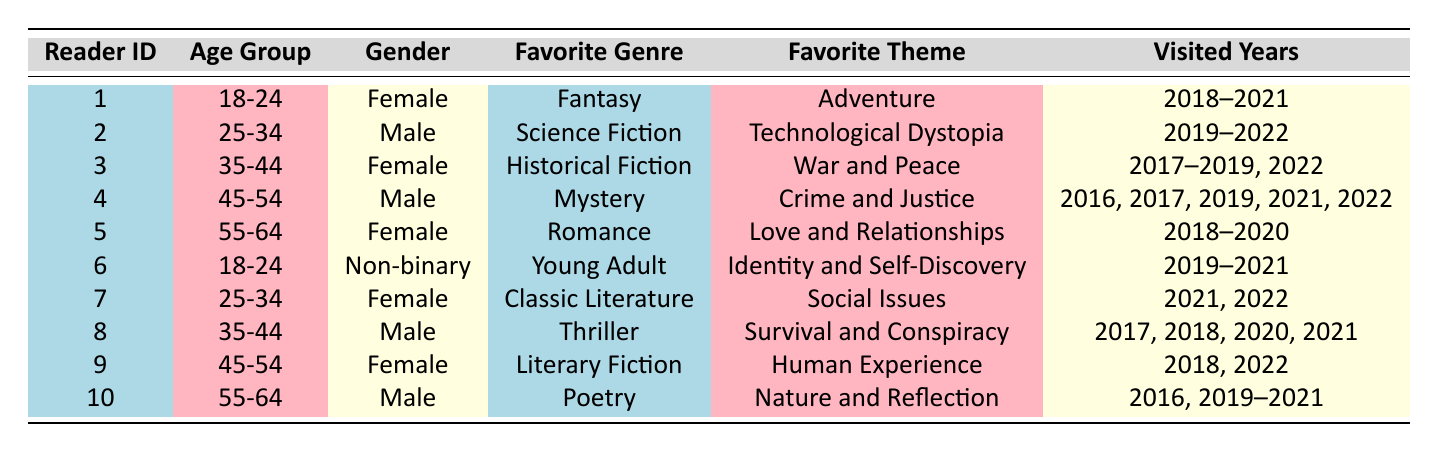What is the favorite genre of the youngest reader? The youngest reader is in the age group 18-24, and looking at the table, we see two readers in this group: Reader 1 and Reader 6. Reader 1's favorite genre is Fantasy, and Reader 6's favorite genre is Young Adult. Since both belong to the same age group, we can state that the favorite genres for the youngest readers are Fantasy and Young Adult.
Answer: Fantasy and Young Adult How many readers have the favorite theme "Social Issues"? To find the number of readers with the favorite theme "Social Issues," we can refer to the table and check for occurrences of this theme. Reader 7 has the theme "Social Issues." As there is only one reader associated with this theme, the count is 1.
Answer: 1 Is there any reader who enjoys both Poetry and the theme "Nature and Reflection"? Checking the table, we find that Reader 10 has the favorite genre of Poetry and the favorite theme of Nature and Reflection. Therefore, there is indeed a reader who enjoys both.
Answer: Yes What is the most common favorite genre among the readers in the age groups 35-44 and 45-54? We need to analyze the age groups of 35-44 and 45-54. In the 35-44 age group, Reader 3 enjoys Historical Fiction and Reader 8 enjoys Thriller. In the 45-54 age group, Reader 4 enjoys Mystery and Reader 9 enjoys Literary Fiction. Each genre only appears once in these groups, so no single genre is more common than another when considering all four readers.
Answer: No common genre What percentage of readers have visited the conference in 2019? To calculate the percentage of readers who visited in 2019, we count the total number of readers (10) and those who visited in 2019. The readers who attended in 2019 are Readers 1, 2, 3, 4, 5, 6, 8, and 10, which amounts to 8 readers. The percentage is (8/10) * 100 = 80%.
Answer: 80% 